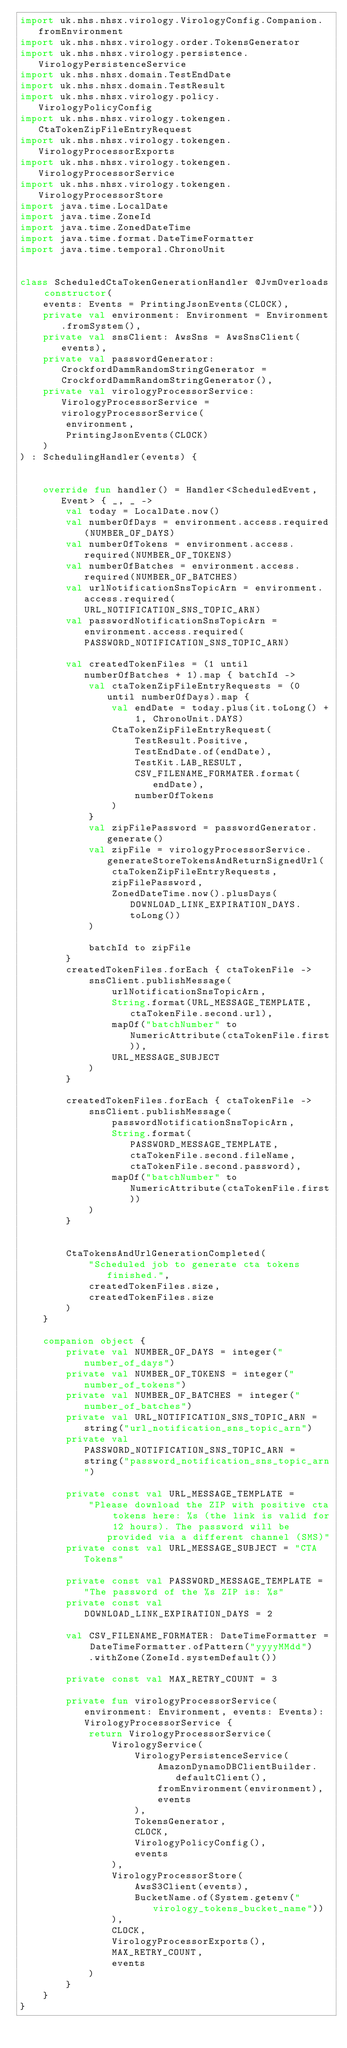Convert code to text. <code><loc_0><loc_0><loc_500><loc_500><_Kotlin_>import uk.nhs.nhsx.virology.VirologyConfig.Companion.fromEnvironment
import uk.nhs.nhsx.virology.order.TokensGenerator
import uk.nhs.nhsx.virology.persistence.VirologyPersistenceService
import uk.nhs.nhsx.domain.TestEndDate
import uk.nhs.nhsx.domain.TestResult
import uk.nhs.nhsx.virology.policy.VirologyPolicyConfig
import uk.nhs.nhsx.virology.tokengen.CtaTokenZipFileEntryRequest
import uk.nhs.nhsx.virology.tokengen.VirologyProcessorExports
import uk.nhs.nhsx.virology.tokengen.VirologyProcessorService
import uk.nhs.nhsx.virology.tokengen.VirologyProcessorStore
import java.time.LocalDate
import java.time.ZoneId
import java.time.ZonedDateTime
import java.time.format.DateTimeFormatter
import java.time.temporal.ChronoUnit


class ScheduledCtaTokenGenerationHandler @JvmOverloads constructor(
    events: Events = PrintingJsonEvents(CLOCK),
    private val environment: Environment = Environment.fromSystem(),
    private val snsClient: AwsSns = AwsSnsClient(events),
    private val passwordGenerator: CrockfordDammRandomStringGenerator = CrockfordDammRandomStringGenerator(),
    private val virologyProcessorService: VirologyProcessorService = virologyProcessorService(
        environment,
        PrintingJsonEvents(CLOCK)
    )
) : SchedulingHandler(events) {


    override fun handler() = Handler<ScheduledEvent, Event> { _, _ ->
        val today = LocalDate.now()
        val numberOfDays = environment.access.required(NUMBER_OF_DAYS)
        val numberOfTokens = environment.access.required(NUMBER_OF_TOKENS)
        val numberOfBatches = environment.access.required(NUMBER_OF_BATCHES)
        val urlNotificationSnsTopicArn = environment.access.required(URL_NOTIFICATION_SNS_TOPIC_ARN)
        val passwordNotificationSnsTopicArn = environment.access.required(PASSWORD_NOTIFICATION_SNS_TOPIC_ARN)

        val createdTokenFiles = (1 until numberOfBatches + 1).map { batchId ->
            val ctaTokenZipFileEntryRequests = (0 until numberOfDays).map {
                val endDate = today.plus(it.toLong() + 1, ChronoUnit.DAYS)
                CtaTokenZipFileEntryRequest(
                    TestResult.Positive,
                    TestEndDate.of(endDate),
                    TestKit.LAB_RESULT,
                    CSV_FILENAME_FORMATER.format(endDate),
                    numberOfTokens
                )
            }
            val zipFilePassword = passwordGenerator.generate()
            val zipFile = virologyProcessorService.generateStoreTokensAndReturnSignedUrl(
                ctaTokenZipFileEntryRequests,
                zipFilePassword,
                ZonedDateTime.now().plusDays(DOWNLOAD_LINK_EXPIRATION_DAYS.toLong())
            )

            batchId to zipFile
        }
        createdTokenFiles.forEach { ctaTokenFile ->
            snsClient.publishMessage(
                urlNotificationSnsTopicArn,
                String.format(URL_MESSAGE_TEMPLATE, ctaTokenFile.second.url),
                mapOf("batchNumber" to NumericAttribute(ctaTokenFile.first)),
                URL_MESSAGE_SUBJECT
            )
        }

        createdTokenFiles.forEach { ctaTokenFile ->
            snsClient.publishMessage(
                passwordNotificationSnsTopicArn,
                String.format(PASSWORD_MESSAGE_TEMPLATE, ctaTokenFile.second.fileName, ctaTokenFile.second.password),
                mapOf("batchNumber" to NumericAttribute(ctaTokenFile.first))
            )
        }


        CtaTokensAndUrlGenerationCompleted(
            "Scheduled job to generate cta tokens finished.",
            createdTokenFiles.size,
            createdTokenFiles.size
        )
    }

    companion object {
        private val NUMBER_OF_DAYS = integer("number_of_days")
        private val NUMBER_OF_TOKENS = integer("number_of_tokens")
        private val NUMBER_OF_BATCHES = integer("number_of_batches")
        private val URL_NOTIFICATION_SNS_TOPIC_ARN = string("url_notification_sns_topic_arn")
        private val PASSWORD_NOTIFICATION_SNS_TOPIC_ARN = string("password_notification_sns_topic_arn")

        private const val URL_MESSAGE_TEMPLATE =
            "Please download the ZIP with positive cta tokens here: %s (the link is valid for 12 hours). The password will be provided via a different channel (SMS)"
        private const val URL_MESSAGE_SUBJECT = "CTA Tokens"

        private const val PASSWORD_MESSAGE_TEMPLATE = "The password of the %s ZIP is: %s"
        private const val DOWNLOAD_LINK_EXPIRATION_DAYS = 2

        val CSV_FILENAME_FORMATER: DateTimeFormatter = DateTimeFormatter.ofPattern("yyyyMMdd")
            .withZone(ZoneId.systemDefault())

        private const val MAX_RETRY_COUNT = 3

        private fun virologyProcessorService(environment: Environment, events: Events): VirologyProcessorService {
            return VirologyProcessorService(
                VirologyService(
                    VirologyPersistenceService(
                        AmazonDynamoDBClientBuilder.defaultClient(),
                        fromEnvironment(environment),
                        events
                    ),
                    TokensGenerator,
                    CLOCK,
                    VirologyPolicyConfig(),
                    events
                ),
                VirologyProcessorStore(
                    AwsS3Client(events),
                    BucketName.of(System.getenv("virology_tokens_bucket_name"))
                ),
                CLOCK,
                VirologyProcessorExports(),
                MAX_RETRY_COUNT,
                events
            )
        }
    }
}
</code> 